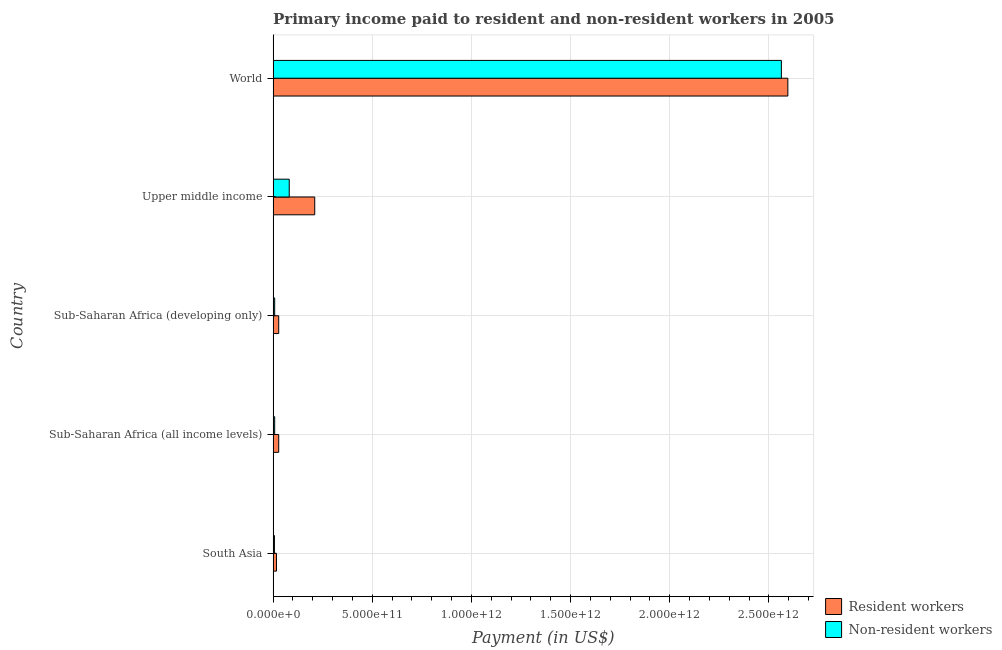How many different coloured bars are there?
Provide a succinct answer. 2. How many groups of bars are there?
Keep it short and to the point. 5. How many bars are there on the 4th tick from the top?
Provide a succinct answer. 2. How many bars are there on the 4th tick from the bottom?
Provide a succinct answer. 2. What is the label of the 4th group of bars from the top?
Provide a short and direct response. Sub-Saharan Africa (all income levels). What is the payment made to non-resident workers in Sub-Saharan Africa (all income levels)?
Give a very brief answer. 7.92e+09. Across all countries, what is the maximum payment made to resident workers?
Your answer should be very brief. 2.60e+12. Across all countries, what is the minimum payment made to resident workers?
Provide a succinct answer. 1.69e+1. In which country was the payment made to non-resident workers minimum?
Your answer should be very brief. South Asia. What is the total payment made to resident workers in the graph?
Your response must be concise. 2.88e+12. What is the difference between the payment made to resident workers in South Asia and that in World?
Ensure brevity in your answer.  -2.58e+12. What is the difference between the payment made to resident workers in World and the payment made to non-resident workers in Upper middle income?
Offer a very short reply. 2.51e+12. What is the average payment made to resident workers per country?
Offer a very short reply. 5.76e+11. What is the difference between the payment made to resident workers and payment made to non-resident workers in Sub-Saharan Africa (all income levels)?
Provide a succinct answer. 2.03e+1. In how many countries, is the payment made to resident workers greater than 2500000000000 US$?
Keep it short and to the point. 1. Is the payment made to non-resident workers in Sub-Saharan Africa (all income levels) less than that in World?
Keep it short and to the point. Yes. Is the difference between the payment made to non-resident workers in Sub-Saharan Africa (developing only) and World greater than the difference between the payment made to resident workers in Sub-Saharan Africa (developing only) and World?
Your answer should be compact. Yes. What is the difference between the highest and the second highest payment made to non-resident workers?
Keep it short and to the point. 2.48e+12. What is the difference between the highest and the lowest payment made to non-resident workers?
Your answer should be compact. 2.56e+12. What does the 1st bar from the top in Sub-Saharan Africa (all income levels) represents?
Provide a succinct answer. Non-resident workers. What does the 2nd bar from the bottom in Sub-Saharan Africa (all income levels) represents?
Provide a succinct answer. Non-resident workers. How many bars are there?
Give a very brief answer. 10. How many countries are there in the graph?
Provide a short and direct response. 5. What is the difference between two consecutive major ticks on the X-axis?
Make the answer very short. 5.00e+11. Does the graph contain any zero values?
Your answer should be very brief. No. Does the graph contain grids?
Your response must be concise. Yes. Where does the legend appear in the graph?
Give a very brief answer. Bottom right. How many legend labels are there?
Offer a terse response. 2. How are the legend labels stacked?
Offer a very short reply. Vertical. What is the title of the graph?
Make the answer very short. Primary income paid to resident and non-resident workers in 2005. Does "Register a property" appear as one of the legend labels in the graph?
Provide a short and direct response. No. What is the label or title of the X-axis?
Offer a very short reply. Payment (in US$). What is the label or title of the Y-axis?
Offer a very short reply. Country. What is the Payment (in US$) in Resident workers in South Asia?
Make the answer very short. 1.69e+1. What is the Payment (in US$) in Non-resident workers in South Asia?
Make the answer very short. 6.66e+09. What is the Payment (in US$) of Resident workers in Sub-Saharan Africa (all income levels)?
Offer a terse response. 2.82e+1. What is the Payment (in US$) of Non-resident workers in Sub-Saharan Africa (all income levels)?
Your answer should be compact. 7.92e+09. What is the Payment (in US$) of Resident workers in Sub-Saharan Africa (developing only)?
Provide a succinct answer. 2.82e+1. What is the Payment (in US$) of Non-resident workers in Sub-Saharan Africa (developing only)?
Your response must be concise. 7.91e+09. What is the Payment (in US$) of Resident workers in Upper middle income?
Give a very brief answer. 2.10e+11. What is the Payment (in US$) of Non-resident workers in Upper middle income?
Offer a terse response. 8.13e+1. What is the Payment (in US$) of Resident workers in World?
Offer a very short reply. 2.60e+12. What is the Payment (in US$) of Non-resident workers in World?
Offer a terse response. 2.56e+12. Across all countries, what is the maximum Payment (in US$) in Resident workers?
Your answer should be compact. 2.60e+12. Across all countries, what is the maximum Payment (in US$) in Non-resident workers?
Your answer should be very brief. 2.56e+12. Across all countries, what is the minimum Payment (in US$) in Resident workers?
Offer a terse response. 1.69e+1. Across all countries, what is the minimum Payment (in US$) in Non-resident workers?
Your response must be concise. 6.66e+09. What is the total Payment (in US$) in Resident workers in the graph?
Make the answer very short. 2.88e+12. What is the total Payment (in US$) of Non-resident workers in the graph?
Provide a succinct answer. 2.67e+12. What is the difference between the Payment (in US$) of Resident workers in South Asia and that in Sub-Saharan Africa (all income levels)?
Make the answer very short. -1.14e+1. What is the difference between the Payment (in US$) in Non-resident workers in South Asia and that in Sub-Saharan Africa (all income levels)?
Your response must be concise. -1.25e+09. What is the difference between the Payment (in US$) of Resident workers in South Asia and that in Sub-Saharan Africa (developing only)?
Give a very brief answer. -1.13e+1. What is the difference between the Payment (in US$) of Non-resident workers in South Asia and that in Sub-Saharan Africa (developing only)?
Your response must be concise. -1.24e+09. What is the difference between the Payment (in US$) in Resident workers in South Asia and that in Upper middle income?
Provide a succinct answer. -1.93e+11. What is the difference between the Payment (in US$) in Non-resident workers in South Asia and that in Upper middle income?
Offer a very short reply. -7.46e+1. What is the difference between the Payment (in US$) of Resident workers in South Asia and that in World?
Keep it short and to the point. -2.58e+12. What is the difference between the Payment (in US$) in Non-resident workers in South Asia and that in World?
Offer a very short reply. -2.56e+12. What is the difference between the Payment (in US$) in Resident workers in Sub-Saharan Africa (all income levels) and that in Sub-Saharan Africa (developing only)?
Provide a succinct answer. 4.99e+07. What is the difference between the Payment (in US$) of Non-resident workers in Sub-Saharan Africa (all income levels) and that in Sub-Saharan Africa (developing only)?
Ensure brevity in your answer.  9.81e+06. What is the difference between the Payment (in US$) of Resident workers in Sub-Saharan Africa (all income levels) and that in Upper middle income?
Your response must be concise. -1.82e+11. What is the difference between the Payment (in US$) of Non-resident workers in Sub-Saharan Africa (all income levels) and that in Upper middle income?
Keep it short and to the point. -7.33e+1. What is the difference between the Payment (in US$) of Resident workers in Sub-Saharan Africa (all income levels) and that in World?
Keep it short and to the point. -2.57e+12. What is the difference between the Payment (in US$) of Non-resident workers in Sub-Saharan Africa (all income levels) and that in World?
Your answer should be compact. -2.55e+12. What is the difference between the Payment (in US$) of Resident workers in Sub-Saharan Africa (developing only) and that in Upper middle income?
Offer a very short reply. -1.82e+11. What is the difference between the Payment (in US$) of Non-resident workers in Sub-Saharan Africa (developing only) and that in Upper middle income?
Offer a very short reply. -7.34e+1. What is the difference between the Payment (in US$) in Resident workers in Sub-Saharan Africa (developing only) and that in World?
Offer a very short reply. -2.57e+12. What is the difference between the Payment (in US$) in Non-resident workers in Sub-Saharan Africa (developing only) and that in World?
Offer a terse response. -2.55e+12. What is the difference between the Payment (in US$) of Resident workers in Upper middle income and that in World?
Your response must be concise. -2.39e+12. What is the difference between the Payment (in US$) in Non-resident workers in Upper middle income and that in World?
Your answer should be very brief. -2.48e+12. What is the difference between the Payment (in US$) of Resident workers in South Asia and the Payment (in US$) of Non-resident workers in Sub-Saharan Africa (all income levels)?
Give a very brief answer. 8.97e+09. What is the difference between the Payment (in US$) in Resident workers in South Asia and the Payment (in US$) in Non-resident workers in Sub-Saharan Africa (developing only)?
Keep it short and to the point. 8.98e+09. What is the difference between the Payment (in US$) of Resident workers in South Asia and the Payment (in US$) of Non-resident workers in Upper middle income?
Keep it short and to the point. -6.44e+1. What is the difference between the Payment (in US$) of Resident workers in South Asia and the Payment (in US$) of Non-resident workers in World?
Ensure brevity in your answer.  -2.55e+12. What is the difference between the Payment (in US$) of Resident workers in Sub-Saharan Africa (all income levels) and the Payment (in US$) of Non-resident workers in Sub-Saharan Africa (developing only)?
Make the answer very short. 2.03e+1. What is the difference between the Payment (in US$) of Resident workers in Sub-Saharan Africa (all income levels) and the Payment (in US$) of Non-resident workers in Upper middle income?
Offer a very short reply. -5.30e+1. What is the difference between the Payment (in US$) of Resident workers in Sub-Saharan Africa (all income levels) and the Payment (in US$) of Non-resident workers in World?
Offer a very short reply. -2.53e+12. What is the difference between the Payment (in US$) of Resident workers in Sub-Saharan Africa (developing only) and the Payment (in US$) of Non-resident workers in Upper middle income?
Give a very brief answer. -5.31e+1. What is the difference between the Payment (in US$) in Resident workers in Sub-Saharan Africa (developing only) and the Payment (in US$) in Non-resident workers in World?
Give a very brief answer. -2.53e+12. What is the difference between the Payment (in US$) of Resident workers in Upper middle income and the Payment (in US$) of Non-resident workers in World?
Offer a very short reply. -2.35e+12. What is the average Payment (in US$) in Resident workers per country?
Offer a very short reply. 5.76e+11. What is the average Payment (in US$) of Non-resident workers per country?
Your response must be concise. 5.33e+11. What is the difference between the Payment (in US$) in Resident workers and Payment (in US$) in Non-resident workers in South Asia?
Ensure brevity in your answer.  1.02e+1. What is the difference between the Payment (in US$) of Resident workers and Payment (in US$) of Non-resident workers in Sub-Saharan Africa (all income levels)?
Ensure brevity in your answer.  2.03e+1. What is the difference between the Payment (in US$) of Resident workers and Payment (in US$) of Non-resident workers in Sub-Saharan Africa (developing only)?
Give a very brief answer. 2.03e+1. What is the difference between the Payment (in US$) in Resident workers and Payment (in US$) in Non-resident workers in Upper middle income?
Provide a succinct answer. 1.29e+11. What is the difference between the Payment (in US$) of Resident workers and Payment (in US$) of Non-resident workers in World?
Offer a terse response. 3.27e+1. What is the ratio of the Payment (in US$) of Resident workers in South Asia to that in Sub-Saharan Africa (all income levels)?
Provide a short and direct response. 0.6. What is the ratio of the Payment (in US$) of Non-resident workers in South Asia to that in Sub-Saharan Africa (all income levels)?
Your response must be concise. 0.84. What is the ratio of the Payment (in US$) in Resident workers in South Asia to that in Sub-Saharan Africa (developing only)?
Give a very brief answer. 0.6. What is the ratio of the Payment (in US$) in Non-resident workers in South Asia to that in Sub-Saharan Africa (developing only)?
Make the answer very short. 0.84. What is the ratio of the Payment (in US$) of Resident workers in South Asia to that in Upper middle income?
Provide a succinct answer. 0.08. What is the ratio of the Payment (in US$) of Non-resident workers in South Asia to that in Upper middle income?
Ensure brevity in your answer.  0.08. What is the ratio of the Payment (in US$) of Resident workers in South Asia to that in World?
Your answer should be compact. 0.01. What is the ratio of the Payment (in US$) in Non-resident workers in South Asia to that in World?
Provide a succinct answer. 0. What is the ratio of the Payment (in US$) of Resident workers in Sub-Saharan Africa (all income levels) to that in Sub-Saharan Africa (developing only)?
Your response must be concise. 1. What is the ratio of the Payment (in US$) in Non-resident workers in Sub-Saharan Africa (all income levels) to that in Sub-Saharan Africa (developing only)?
Offer a very short reply. 1. What is the ratio of the Payment (in US$) in Resident workers in Sub-Saharan Africa (all income levels) to that in Upper middle income?
Offer a very short reply. 0.13. What is the ratio of the Payment (in US$) of Non-resident workers in Sub-Saharan Africa (all income levels) to that in Upper middle income?
Ensure brevity in your answer.  0.1. What is the ratio of the Payment (in US$) in Resident workers in Sub-Saharan Africa (all income levels) to that in World?
Ensure brevity in your answer.  0.01. What is the ratio of the Payment (in US$) of Non-resident workers in Sub-Saharan Africa (all income levels) to that in World?
Your response must be concise. 0. What is the ratio of the Payment (in US$) in Resident workers in Sub-Saharan Africa (developing only) to that in Upper middle income?
Keep it short and to the point. 0.13. What is the ratio of the Payment (in US$) of Non-resident workers in Sub-Saharan Africa (developing only) to that in Upper middle income?
Your answer should be compact. 0.1. What is the ratio of the Payment (in US$) of Resident workers in Sub-Saharan Africa (developing only) to that in World?
Give a very brief answer. 0.01. What is the ratio of the Payment (in US$) in Non-resident workers in Sub-Saharan Africa (developing only) to that in World?
Offer a very short reply. 0. What is the ratio of the Payment (in US$) in Resident workers in Upper middle income to that in World?
Provide a short and direct response. 0.08. What is the ratio of the Payment (in US$) in Non-resident workers in Upper middle income to that in World?
Your answer should be very brief. 0.03. What is the difference between the highest and the second highest Payment (in US$) in Resident workers?
Provide a short and direct response. 2.39e+12. What is the difference between the highest and the second highest Payment (in US$) of Non-resident workers?
Provide a succinct answer. 2.48e+12. What is the difference between the highest and the lowest Payment (in US$) of Resident workers?
Give a very brief answer. 2.58e+12. What is the difference between the highest and the lowest Payment (in US$) of Non-resident workers?
Offer a terse response. 2.56e+12. 